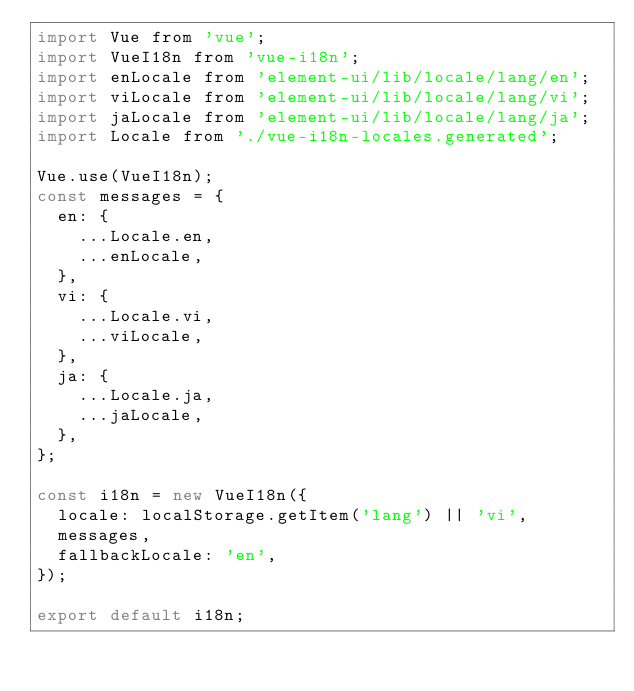<code> <loc_0><loc_0><loc_500><loc_500><_JavaScript_>import Vue from 'vue';
import VueI18n from 'vue-i18n';
import enLocale from 'element-ui/lib/locale/lang/en';
import viLocale from 'element-ui/lib/locale/lang/vi';
import jaLocale from 'element-ui/lib/locale/lang/ja';
import Locale from './vue-i18n-locales.generated';

Vue.use(VueI18n);
const messages = {
  en: {
    ...Locale.en,
    ...enLocale,
  },
  vi: {
    ...Locale.vi,
    ...viLocale,
  },
  ja: {
    ...Locale.ja,
    ...jaLocale,
  },
};

const i18n = new VueI18n({
  locale: localStorage.getItem('lang') || 'vi',
  messages,
  fallbackLocale: 'en',
});

export default i18n;
</code> 